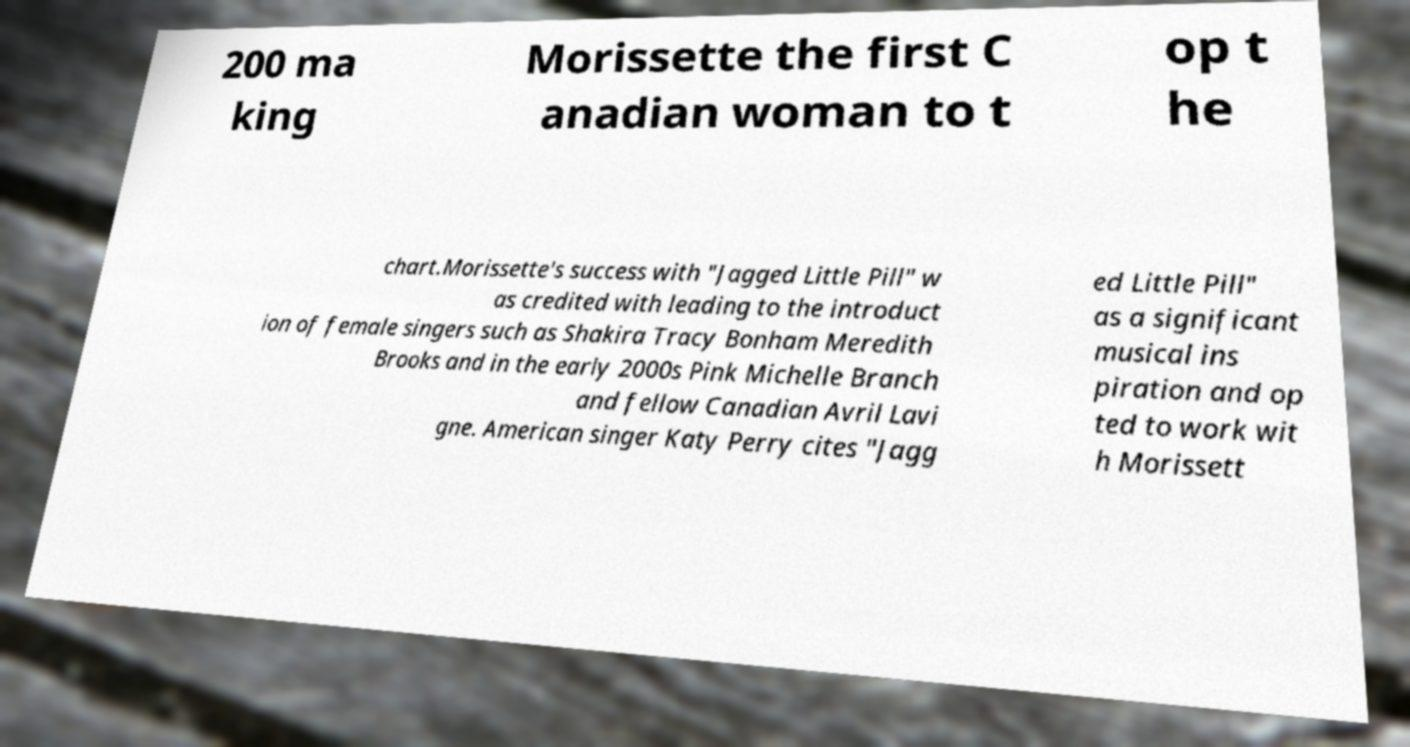Could you assist in decoding the text presented in this image and type it out clearly? 200 ma king Morissette the first C anadian woman to t op t he chart.Morissette's success with "Jagged Little Pill" w as credited with leading to the introduct ion of female singers such as Shakira Tracy Bonham Meredith Brooks and in the early 2000s Pink Michelle Branch and fellow Canadian Avril Lavi gne. American singer Katy Perry cites "Jagg ed Little Pill" as a significant musical ins piration and op ted to work wit h Morissett 